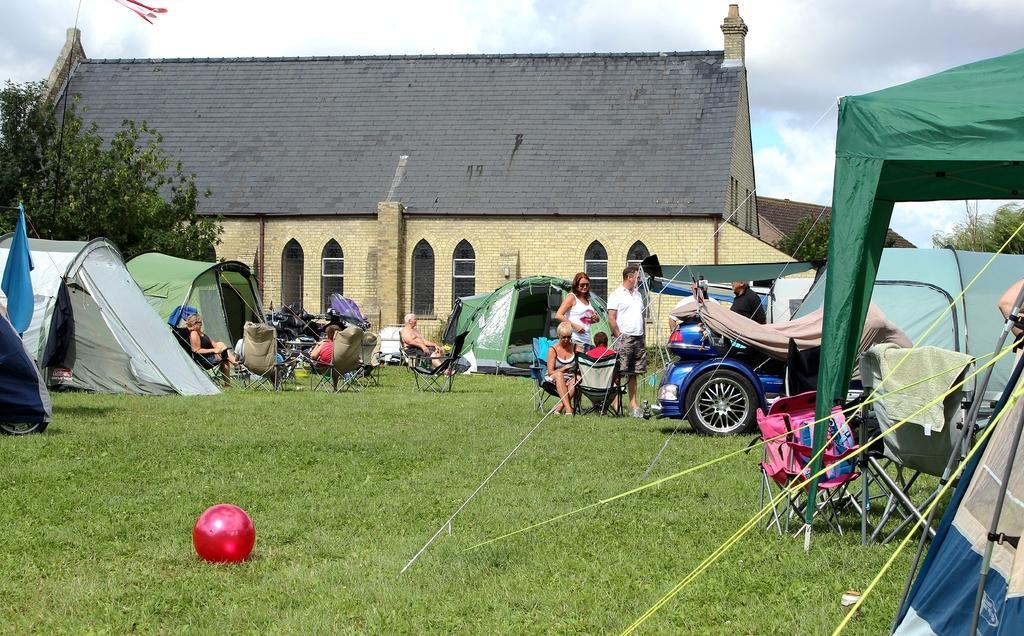Please provide a concise description of this image. In this picture I can see few tents, few vehicles and few people sitting on chairs and rest of them standing. I can also see a red color ball on the grass. In the background I can see 2 buildings, few trees and the cloudy sky. 